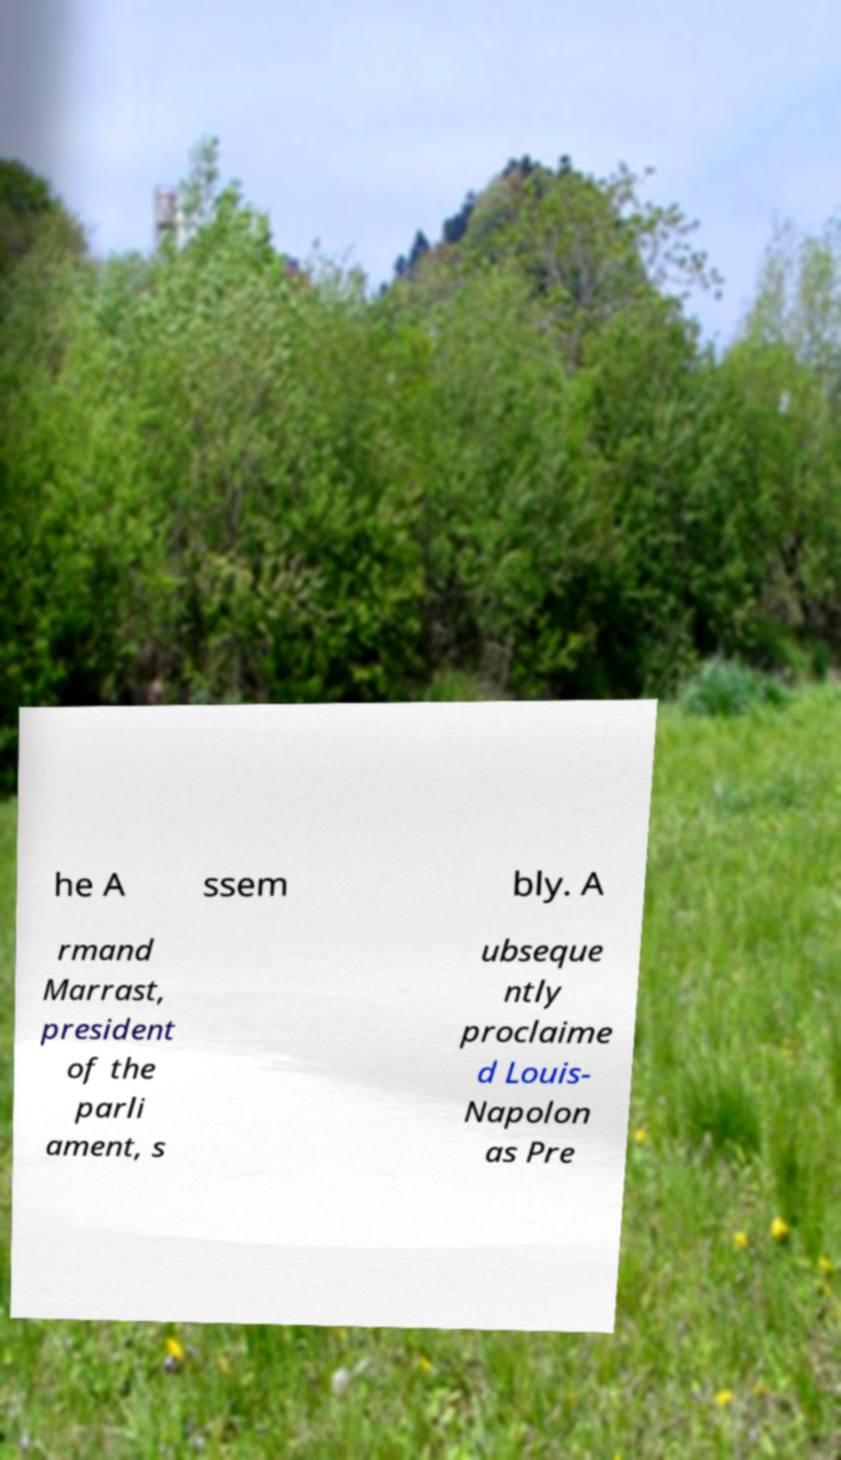Can you read and provide the text displayed in the image?This photo seems to have some interesting text. Can you extract and type it out for me? he A ssem bly. A rmand Marrast, president of the parli ament, s ubseque ntly proclaime d Louis- Napolon as Pre 